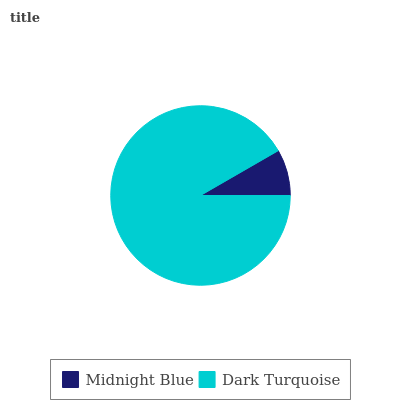Is Midnight Blue the minimum?
Answer yes or no. Yes. Is Dark Turquoise the maximum?
Answer yes or no. Yes. Is Dark Turquoise the minimum?
Answer yes or no. No. Is Dark Turquoise greater than Midnight Blue?
Answer yes or no. Yes. Is Midnight Blue less than Dark Turquoise?
Answer yes or no. Yes. Is Midnight Blue greater than Dark Turquoise?
Answer yes or no. No. Is Dark Turquoise less than Midnight Blue?
Answer yes or no. No. Is Dark Turquoise the high median?
Answer yes or no. Yes. Is Midnight Blue the low median?
Answer yes or no. Yes. Is Midnight Blue the high median?
Answer yes or no. No. Is Dark Turquoise the low median?
Answer yes or no. No. 